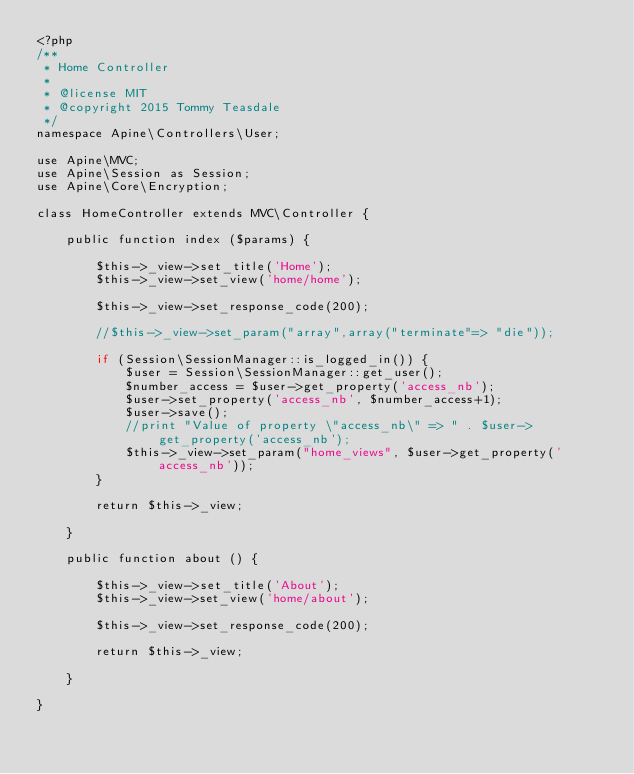<code> <loc_0><loc_0><loc_500><loc_500><_PHP_><?php
/**
 * Home Controller
 *
 * @license MIT
 * @copyright 2015 Tommy Teasdale
 */
namespace Apine\Controllers\User;

use Apine\MVC;
use Apine\Session as Session;
use Apine\Core\Encryption;

class HomeController extends MVC\Controller {
	
	public function index ($params) {
		
		$this->_view->set_title('Home');
		$this->_view->set_view('home/home');
		
		$this->_view->set_response_code(200);
		
		//$this->_view->set_param("array",array("terminate"=> "die"));
		
		if (Session\SessionManager::is_logged_in()) {
			$user = Session\SessionManager::get_user();
			$number_access = $user->get_property('access_nb');
			$user->set_property('access_nb', $number_access+1);
			$user->save();
			//print "Value of property \"access_nb\" => " . $user->get_property('access_nb');
			$this->_view->set_param("home_views", $user->get_property('access_nb'));
		}
		
		return $this->_view;
		
	}
	
	public function about () {
		
		$this->_view->set_title('About');
		$this->_view->set_view('home/about');
	
		$this->_view->set_response_code(200);
		
		return $this->_view;
		
	}
	
}</code> 